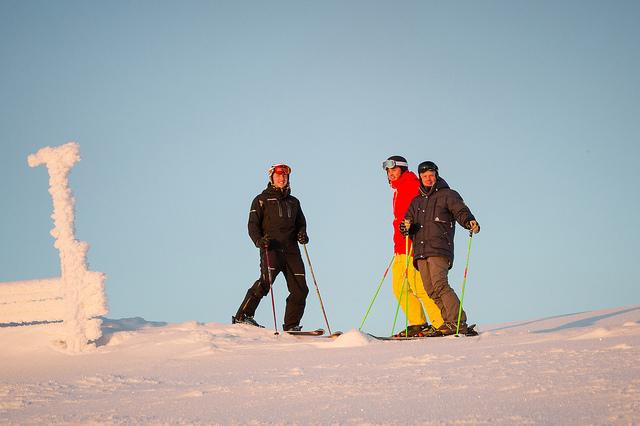Has this trail recently been groomed?
Give a very brief answer. No. Is there an umbrella around?
Short answer required. No. Is the man in gray under 20 years old?
Answer briefly. No. What is the temperature?
Answer briefly. Cold. What color is the middle persons coat?
Write a very short answer. Red. Is that a snowman in the left of the photograph?
Answer briefly. No. How many people are standing?
Answer briefly. 3. 